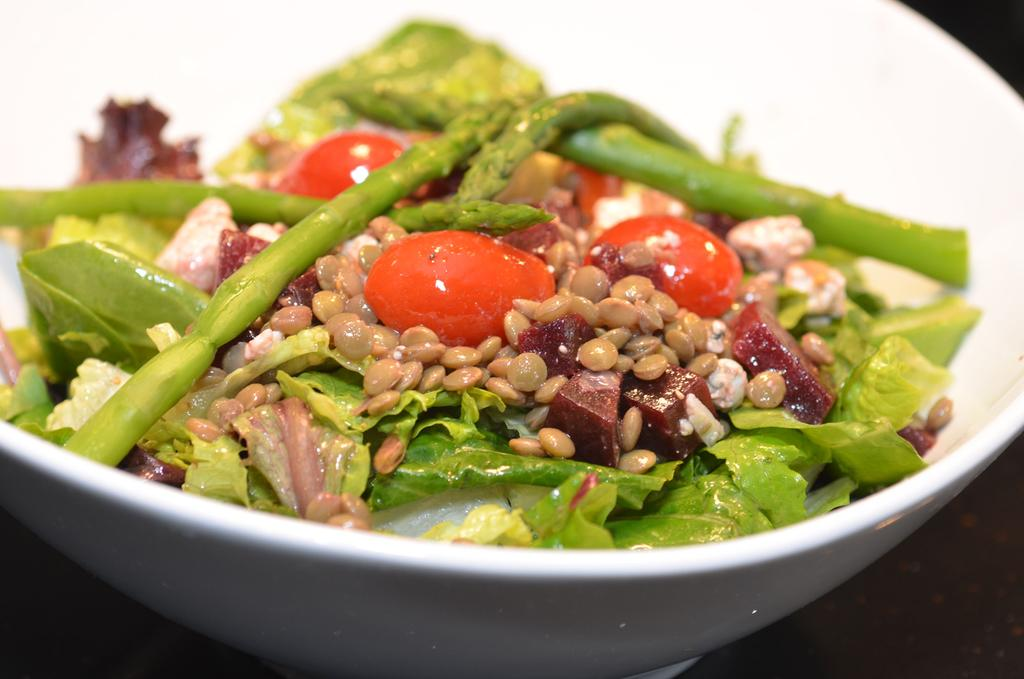What is in the bowl that is visible in the image? There are eatable things in the bowl in the image. Can you describe the items in the bowl? There are items in the bowl, but the specific type of eatable things is not mentioned in the facts. Where is the bowl located in the image? The bowl is placed on a surface in the image. How does the comb help the visitor in the image? There is no mention of a visitor or a comb in the image, so it is not possible to answer this question. 